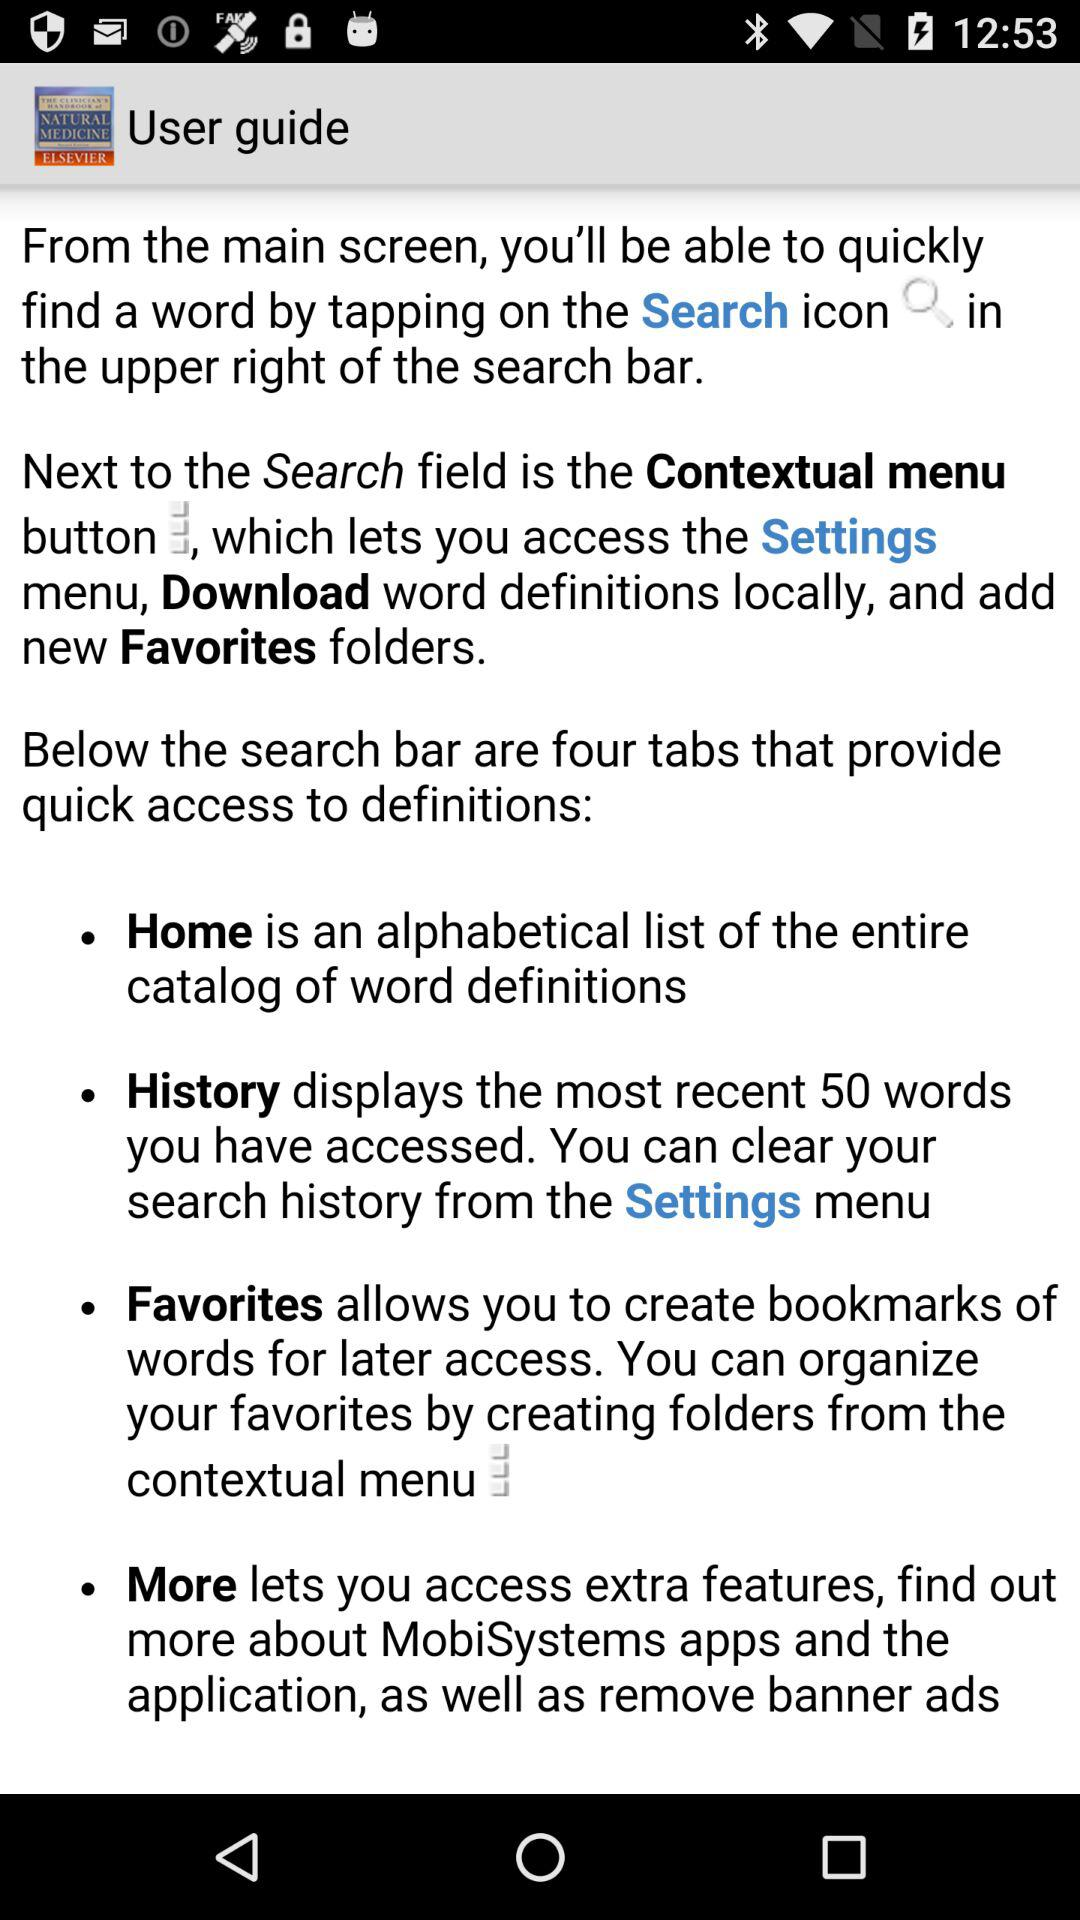How many tabs are below the search bar?
Answer the question using a single word or phrase. 4 